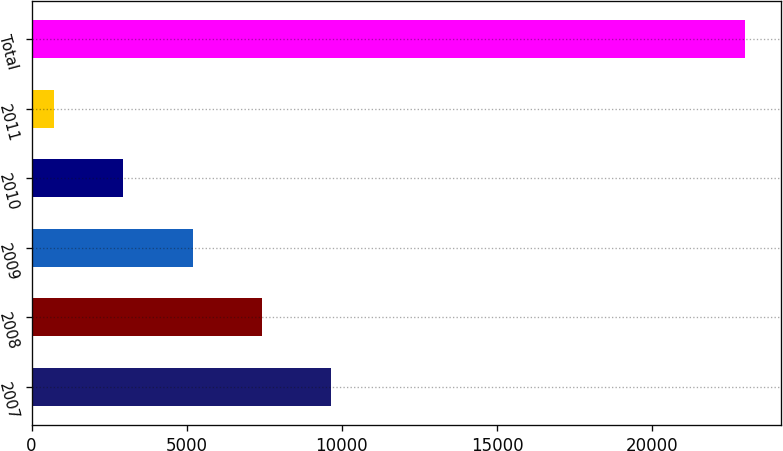Convert chart. <chart><loc_0><loc_0><loc_500><loc_500><bar_chart><fcel>2007<fcel>2008<fcel>2009<fcel>2010<fcel>2011<fcel>Total<nl><fcel>9640.2<fcel>7413.9<fcel>5187.6<fcel>2961.3<fcel>735<fcel>22998<nl></chart> 